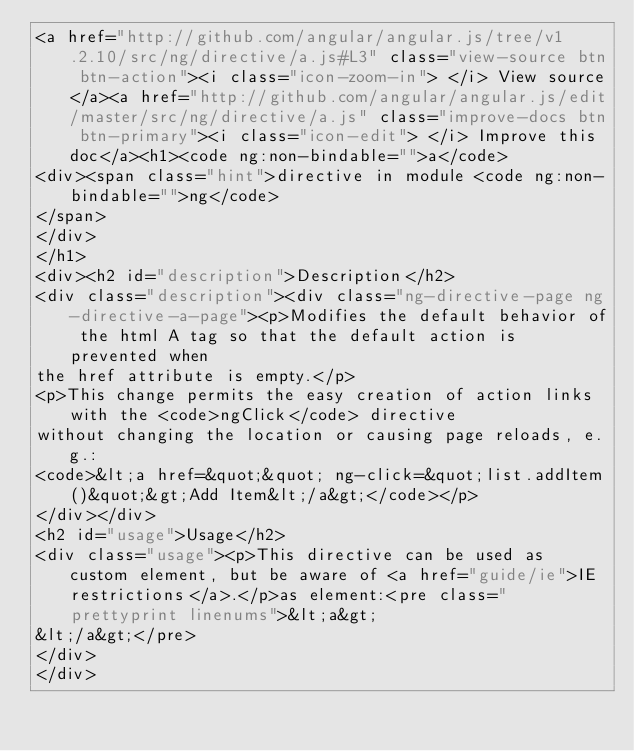Convert code to text. <code><loc_0><loc_0><loc_500><loc_500><_HTML_><a href="http://github.com/angular/angular.js/tree/v1.2.10/src/ng/directive/a.js#L3" class="view-source btn btn-action"><i class="icon-zoom-in"> </i> View source</a><a href="http://github.com/angular/angular.js/edit/master/src/ng/directive/a.js" class="improve-docs btn btn-primary"><i class="icon-edit"> </i> Improve this doc</a><h1><code ng:non-bindable="">a</code>
<div><span class="hint">directive in module <code ng:non-bindable="">ng</code>
</span>
</div>
</h1>
<div><h2 id="description">Description</h2>
<div class="description"><div class="ng-directive-page ng-directive-a-page"><p>Modifies the default behavior of the html A tag so that the default action is prevented when
the href attribute is empty.</p>
<p>This change permits the easy creation of action links with the <code>ngClick</code> directive
without changing the location or causing page reloads, e.g.:
<code>&lt;a href=&quot;&quot; ng-click=&quot;list.addItem()&quot;&gt;Add Item&lt;/a&gt;</code></p>
</div></div>
<h2 id="usage">Usage</h2>
<div class="usage"><p>This directive can be used as custom element, but be aware of <a href="guide/ie">IE restrictions</a>.</p>as element:<pre class="prettyprint linenums">&lt;a&gt;
&lt;/a&gt;</pre>
</div>
</div>
</code> 